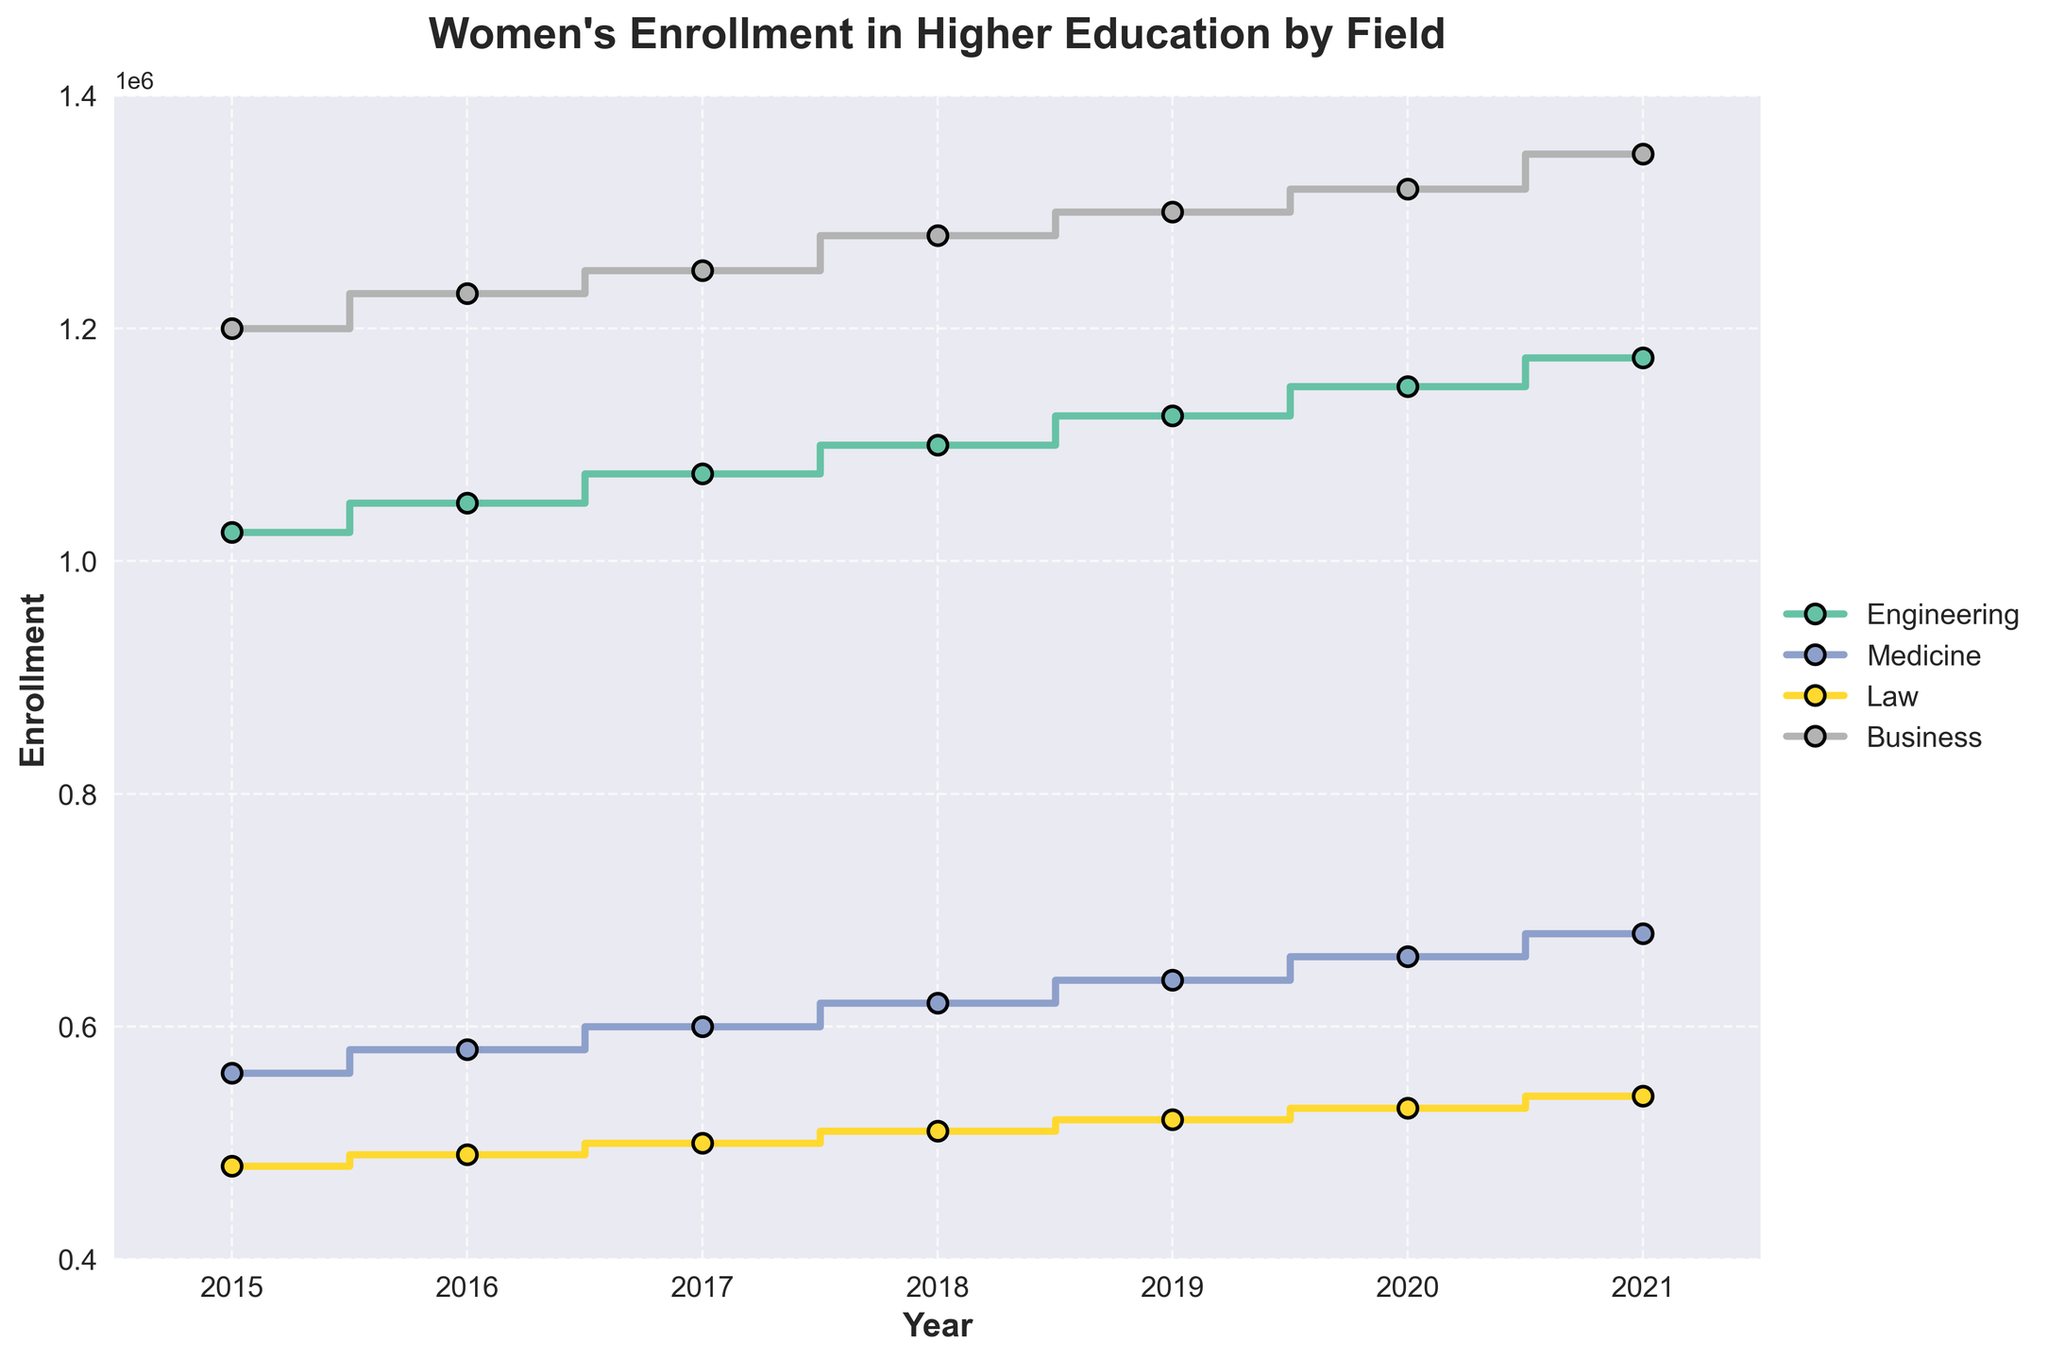What is the title of the plot? The title of the plot is displayed at the top and is in a bold, larger font compared to other text elements.
Answer: Women's Enrollment in Higher Education by Field How many years of data are shown in the plot? The x-axis displays the years, starting from 2015 and ending in 2021. Counting these years gives a total.
Answer: 7 Which field had the highest enrollment in 2015? Look at the starting points of the lines in 2015 and identify the one with the highest value on the y-axis.
Answer: Business What was the enrollment in Medicine in 2018? Find the Medicine line and look for the corresponding y-value at the 2018 mark on the x-axis.
Answer: 620,000 By how much did the enrollment in Engineering increase from 2015 to 2021? Look at the y-value for Engineering in 2015 and subtract it from the y-value in 2021.
Answer: 150,000 Which field experienced the smallest increase in enrollment from 2015 to 2021? Calculate the difference in enrollment for each field between 2015 and 2021, and identify the smallest difference.
Answer: Law Which field shows a consistent increase in enrollment every year? Observe the lines to see which ones continually rise without any dips from 2015 to 2021.
Answer: Medicine, Business, Engineering, Law Compare the enrollment in Law with that in Medicine in 2020. Which one had more students? Look at the values for Law and Medicine in 2020 and compare them.
Answer: Medicine In what year did Business enrollment reach 1,350,000? Find the point on the Business line where the enrollment reaches 1,350,000 and note the corresponding year.
Answer: 2021 Does any field show a decline in enrollment at any point from 2015 to 2021? Examine each line to see if there are any downward steps within the given years.
Answer: No 